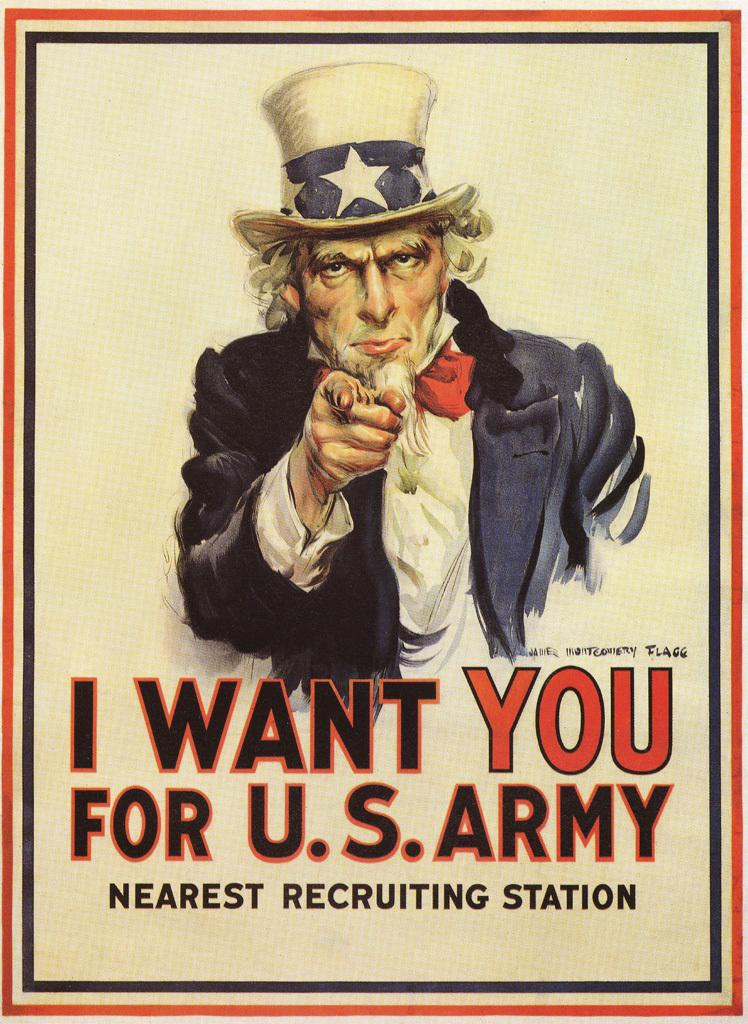<image>
Present a compact description of the photo's key features. a poster of uncle sam saying i want you for the US Army 